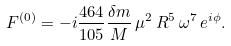<formula> <loc_0><loc_0><loc_500><loc_500>F ^ { ( 0 ) } = - i \frac { 4 6 4 } { 1 0 5 } \frac { \delta m } { M } \, \mu ^ { 2 } \, R ^ { 5 } \, \omega ^ { 7 } \, e ^ { i \phi } .</formula> 